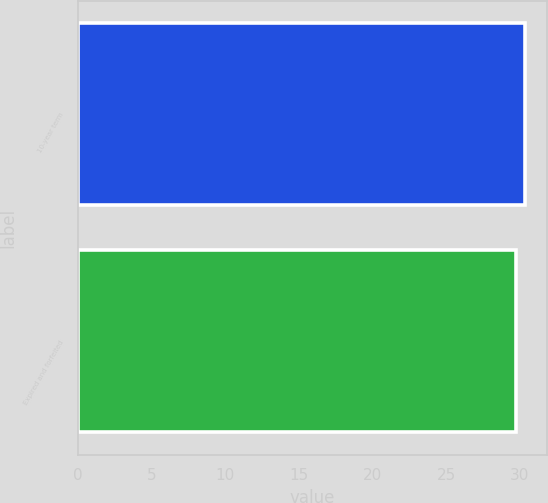Convert chart. <chart><loc_0><loc_0><loc_500><loc_500><bar_chart><fcel>10-year term<fcel>Expired and forfeited<nl><fcel>30.33<fcel>29.75<nl></chart> 